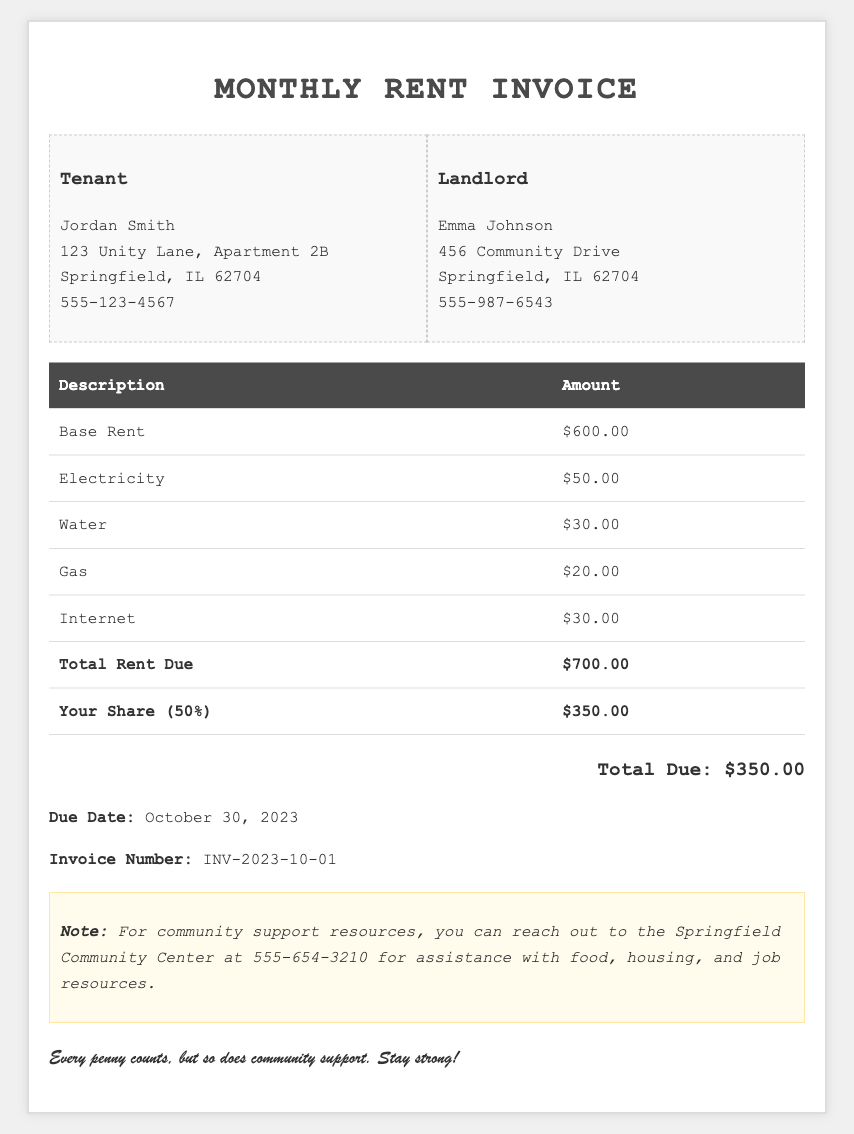what is the total rent due? The total rent due is calculated by summing the base rent and all utilities, and it's displayed at the bottom of the invoice.
Answer: $700.00 how much is your share? Your share is mentioned in the invoice as half of the total rent due.
Answer: $350.00 what is the due date? The due date is explicitly stated in the invoice, indicating when the payment is expected.
Answer: October 30, 2023 who is the landlord? The landlord's name is provided in the information section of the invoice.
Answer: Emma Johnson how much is the electricity charge? The electricity charge is listed under the utility breakdown table in the invoice.
Answer: $50.00 what is the invoice number? The invoice number is a unique identifier for this document, mentioned at the end.
Answer: INV-2023-10-01 what percentage of the total rent due do you pay? The percentage of total rent due you pay is inferred from the document’s breakdown of your share.
Answer: 50% what community resource is mentioned? The community resource details are included in the note at the bottom of the invoice.
Answer: Springfield Community Center how much is the gas charge? The gas charge is specified as part of the utility costs in the breakdown table.
Answer: $20.00 